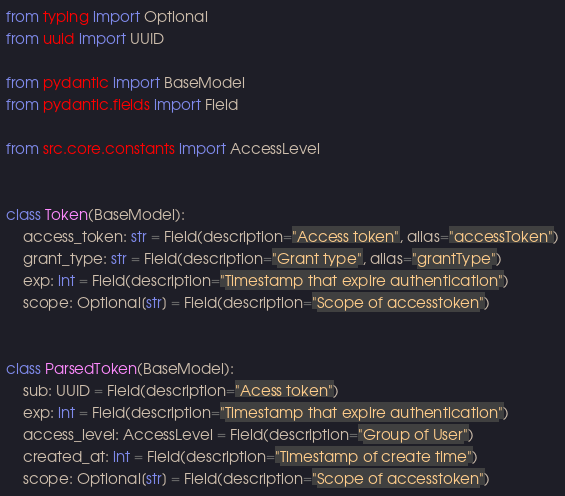<code> <loc_0><loc_0><loc_500><loc_500><_Python_>from typing import Optional
from uuid import UUID

from pydantic import BaseModel
from pydantic.fields import Field

from src.core.constants import AccessLevel


class Token(BaseModel):
    access_token: str = Field(description="Access token", alias="accessToken")
    grant_type: str = Field(description="Grant type", alias="grantType")
    exp: int = Field(description="Timestamp that expire authentication")
    scope: Optional[str] = Field(description="Scope of accesstoken")


class ParsedToken(BaseModel):
    sub: UUID = Field(description="Acess token")
    exp: int = Field(description="Timestamp that expire authentication")
    access_level: AccessLevel = Field(description="Group of User")
    created_at: int = Field(description="Timestamp of create time")
    scope: Optional[str] = Field(description="Scope of accesstoken")
</code> 